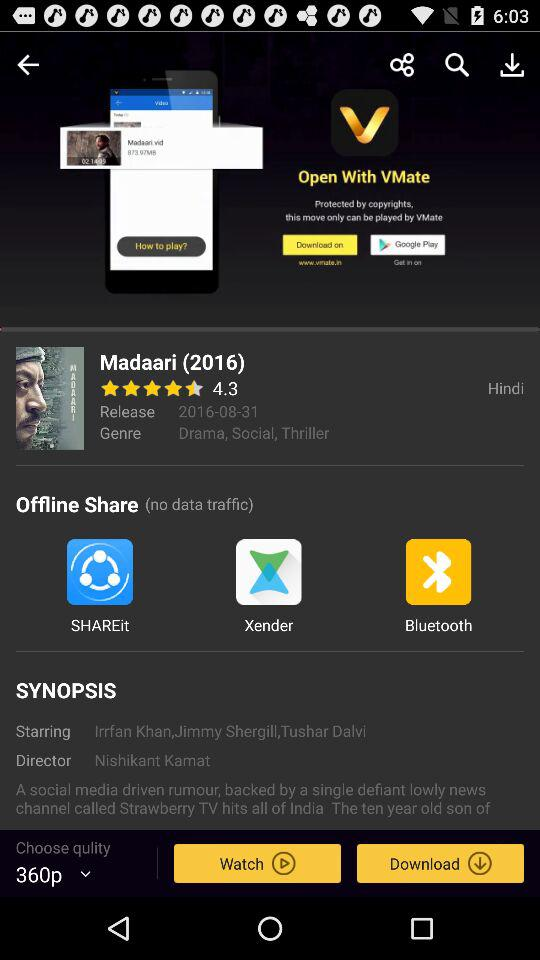What are the names of the star cast? The names of the star cast are Irrfan Khan, Jimmy Shergill and Tushar Dalvi. 